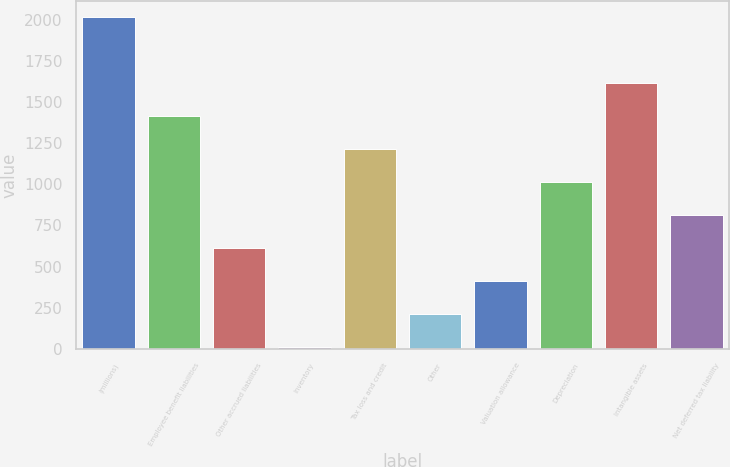Convert chart. <chart><loc_0><loc_0><loc_500><loc_500><bar_chart><fcel>(millions)<fcel>Employee benefit liabilities<fcel>Other accrued liabilities<fcel>Inventory<fcel>Tax loss and credit<fcel>Other<fcel>Valuation allowance<fcel>Depreciation<fcel>Intangible assets<fcel>Net deferred tax liability<nl><fcel>2014<fcel>1413.04<fcel>611.76<fcel>10.8<fcel>1212.72<fcel>211.12<fcel>411.44<fcel>1012.4<fcel>1613.36<fcel>812.08<nl></chart> 